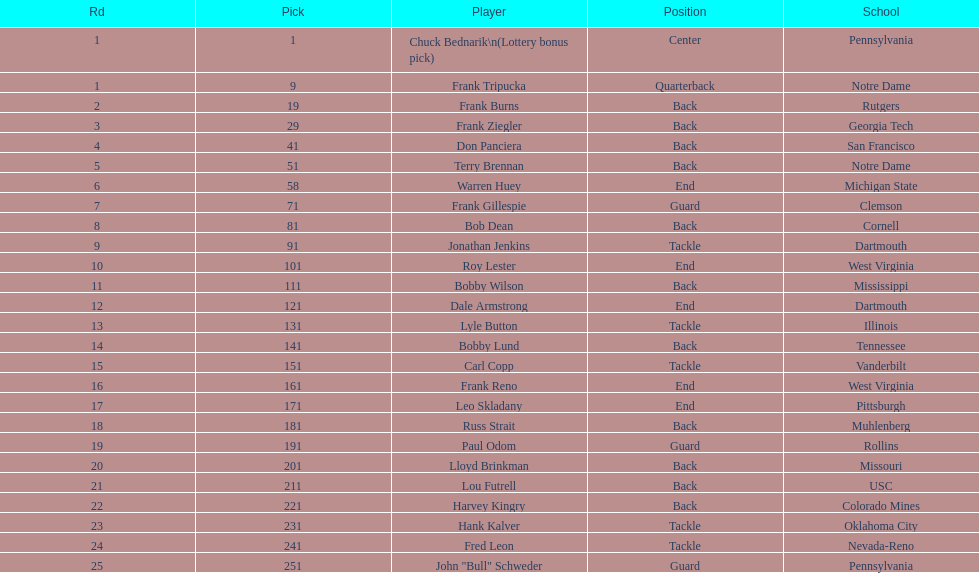What is the number of draft selections between frank tripucka and dale armstrong? 10. 